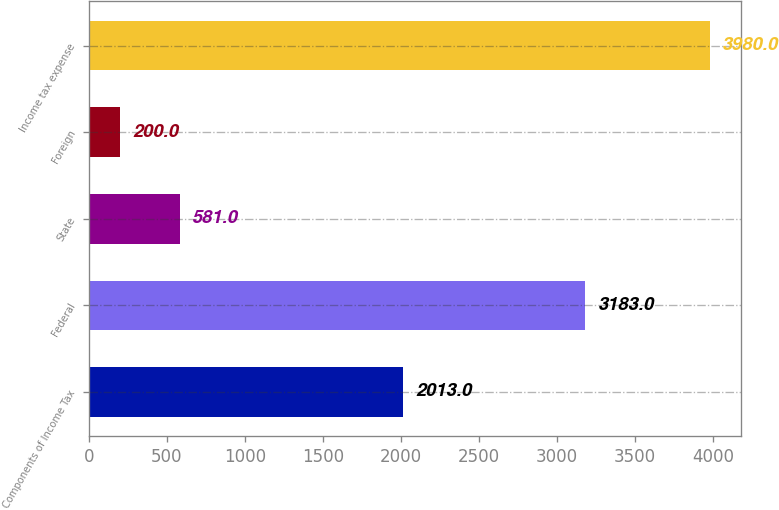Convert chart. <chart><loc_0><loc_0><loc_500><loc_500><bar_chart><fcel>Components of Income Tax<fcel>Federal<fcel>State<fcel>Foreign<fcel>Income tax expense<nl><fcel>2013<fcel>3183<fcel>581<fcel>200<fcel>3980<nl></chart> 